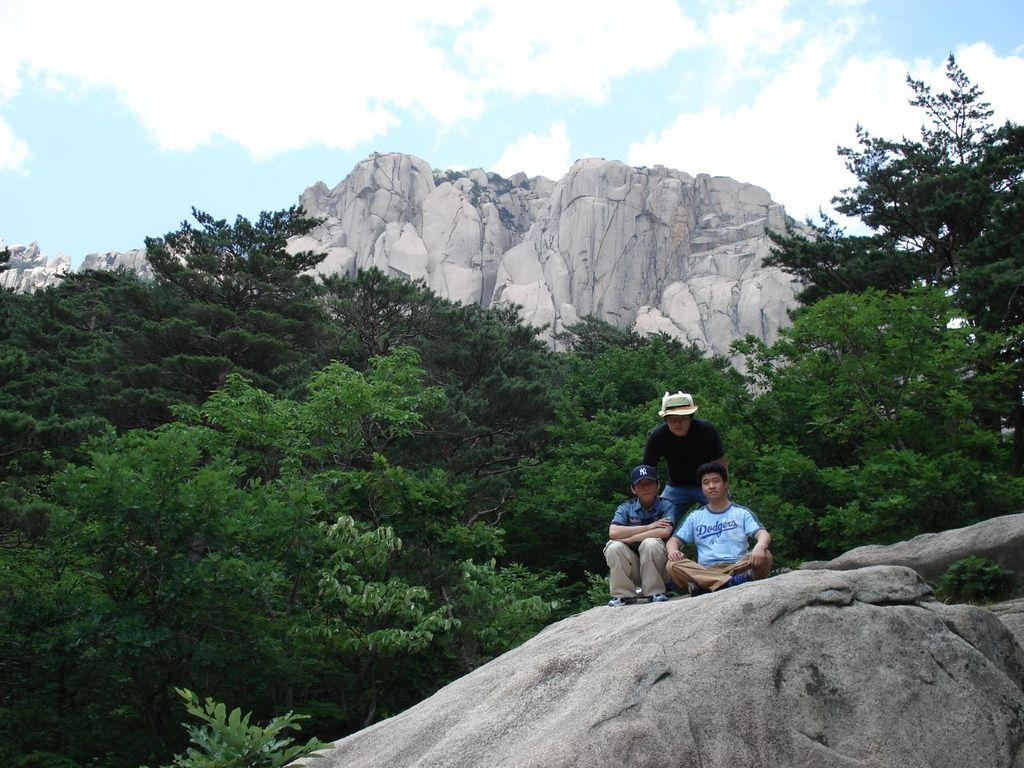How many people are in the image? There are three persons in the image. What are the positions of the two persons on the rock? Two of the persons are sitting on a rock. What is the position of the third person? One person is standing. What can be seen in the background of the image? There are trees, a mountain, and the sky visible in the background of the image. What type of suit is the person wearing in the image? There is no mention of a suit in the image; the people are not wearing any clothing mentioned in the facts. 